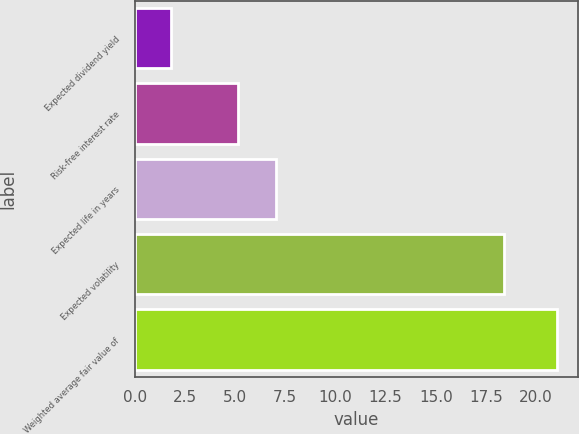<chart> <loc_0><loc_0><loc_500><loc_500><bar_chart><fcel>Expected dividend yield<fcel>Risk-free interest rate<fcel>Expected life in years<fcel>Expected volatility<fcel>Weighted average fair value of<nl><fcel>1.8<fcel>5.13<fcel>7.05<fcel>18.42<fcel>21.05<nl></chart> 